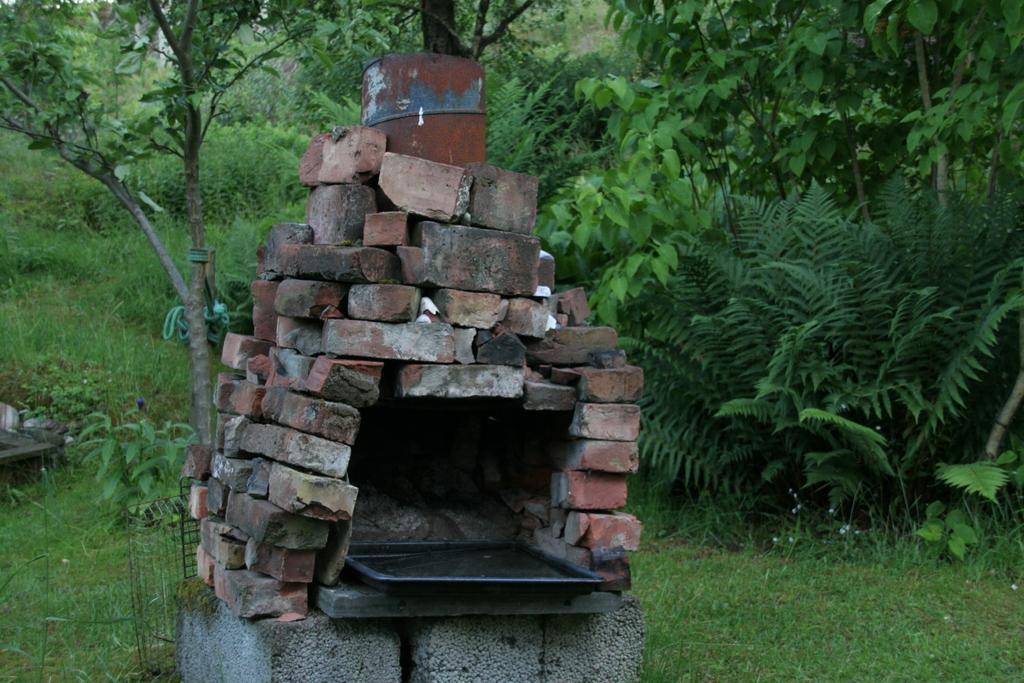What is the main structure in the image? There is a large pyramid in the image. What is the pyramid made of? The pyramid is made up of bricks. What can be seen in the background of the image? There is grass, plants, and trees in the background of the image. How many types of vegetation are visible in the background? There are three types of vegetation visible in the background: grass, plants, and trees. How many sisters are standing next to the pyramid in the image? There are no sisters present in the image; it only features a large pyramid and the surrounding vegetation. 